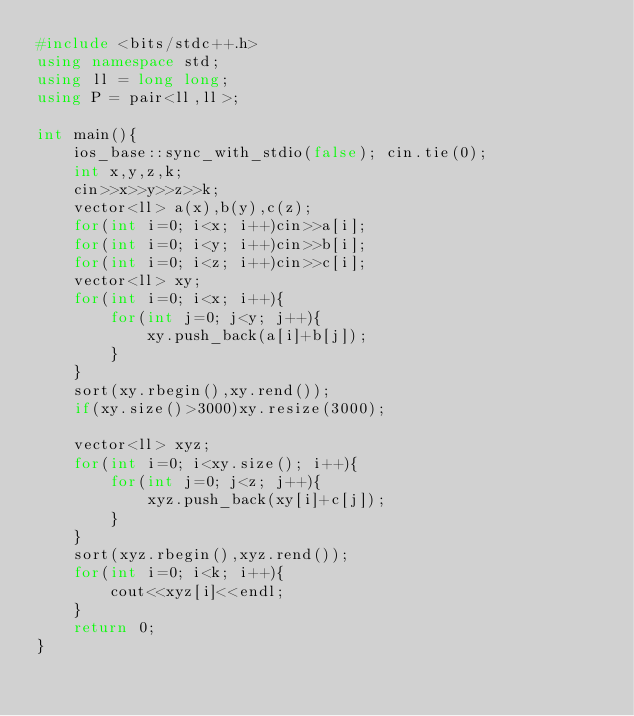Convert code to text. <code><loc_0><loc_0><loc_500><loc_500><_C++_>#include <bits/stdc++.h>
using namespace std;
using ll = long long;
using P = pair<ll,ll>;

int main(){
    ios_base::sync_with_stdio(false); cin.tie(0);
    int x,y,z,k;
    cin>>x>>y>>z>>k;
    vector<ll> a(x),b(y),c(z);
    for(int i=0; i<x; i++)cin>>a[i];
    for(int i=0; i<y; i++)cin>>b[i];
    for(int i=0; i<z; i++)cin>>c[i];
    vector<ll> xy;
    for(int i=0; i<x; i++){
        for(int j=0; j<y; j++){
            xy.push_back(a[i]+b[j]);
        }
    }
    sort(xy.rbegin(),xy.rend());
    if(xy.size()>3000)xy.resize(3000);

    vector<ll> xyz;
    for(int i=0; i<xy.size(); i++){
        for(int j=0; j<z; j++){
            xyz.push_back(xy[i]+c[j]);
        }
    }
    sort(xyz.rbegin(),xyz.rend());
    for(int i=0; i<k; i++){
        cout<<xyz[i]<<endl;
    }
    return 0;
}</code> 